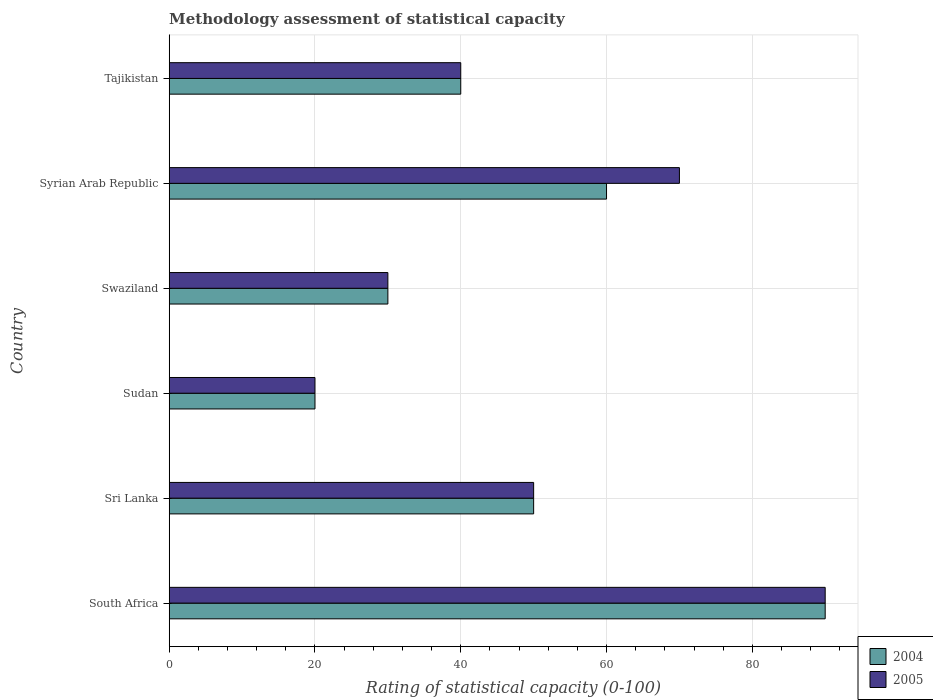How many different coloured bars are there?
Keep it short and to the point. 2. Are the number of bars on each tick of the Y-axis equal?
Your answer should be compact. Yes. How many bars are there on the 3rd tick from the top?
Your answer should be compact. 2. What is the label of the 2nd group of bars from the top?
Offer a very short reply. Syrian Arab Republic. In how many cases, is the number of bars for a given country not equal to the number of legend labels?
Offer a terse response. 0. What is the rating of statistical capacity in 2004 in Swaziland?
Your answer should be compact. 30. Across all countries, what is the minimum rating of statistical capacity in 2005?
Make the answer very short. 20. In which country was the rating of statistical capacity in 2004 maximum?
Give a very brief answer. South Africa. In which country was the rating of statistical capacity in 2005 minimum?
Give a very brief answer. Sudan. What is the total rating of statistical capacity in 2005 in the graph?
Your response must be concise. 300. What is the difference between the rating of statistical capacity in 2005 and rating of statistical capacity in 2004 in Sudan?
Keep it short and to the point. 0. Is the rating of statistical capacity in 2005 in Sri Lanka less than that in Swaziland?
Your answer should be compact. No. What is the difference between the highest and the second highest rating of statistical capacity in 2004?
Keep it short and to the point. 30. In how many countries, is the rating of statistical capacity in 2005 greater than the average rating of statistical capacity in 2005 taken over all countries?
Keep it short and to the point. 2. Is the sum of the rating of statistical capacity in 2004 in Sri Lanka and Sudan greater than the maximum rating of statistical capacity in 2005 across all countries?
Keep it short and to the point. No. Does the graph contain grids?
Give a very brief answer. Yes. How are the legend labels stacked?
Ensure brevity in your answer.  Vertical. What is the title of the graph?
Keep it short and to the point. Methodology assessment of statistical capacity. What is the label or title of the X-axis?
Offer a terse response. Rating of statistical capacity (0-100). What is the label or title of the Y-axis?
Your response must be concise. Country. What is the Rating of statistical capacity (0-100) of 2004 in Sri Lanka?
Give a very brief answer. 50. What is the Rating of statistical capacity (0-100) of 2004 in Sudan?
Your answer should be very brief. 20. What is the Rating of statistical capacity (0-100) of 2005 in Sudan?
Provide a succinct answer. 20. What is the Rating of statistical capacity (0-100) in 2004 in Swaziland?
Provide a short and direct response. 30. What is the Rating of statistical capacity (0-100) in 2005 in Swaziland?
Ensure brevity in your answer.  30. What is the Rating of statistical capacity (0-100) in 2004 in Syrian Arab Republic?
Provide a succinct answer. 60. What is the Rating of statistical capacity (0-100) in 2004 in Tajikistan?
Provide a short and direct response. 40. What is the Rating of statistical capacity (0-100) of 2005 in Tajikistan?
Your answer should be compact. 40. Across all countries, what is the maximum Rating of statistical capacity (0-100) of 2005?
Keep it short and to the point. 90. What is the total Rating of statistical capacity (0-100) of 2004 in the graph?
Give a very brief answer. 290. What is the total Rating of statistical capacity (0-100) of 2005 in the graph?
Your answer should be very brief. 300. What is the difference between the Rating of statistical capacity (0-100) of 2004 in South Africa and that in Sri Lanka?
Provide a succinct answer. 40. What is the difference between the Rating of statistical capacity (0-100) of 2004 in South Africa and that in Syrian Arab Republic?
Keep it short and to the point. 30. What is the difference between the Rating of statistical capacity (0-100) in 2004 in South Africa and that in Tajikistan?
Provide a short and direct response. 50. What is the difference between the Rating of statistical capacity (0-100) in 2005 in South Africa and that in Tajikistan?
Your answer should be compact. 50. What is the difference between the Rating of statistical capacity (0-100) of 2004 in Sri Lanka and that in Swaziland?
Keep it short and to the point. 20. What is the difference between the Rating of statistical capacity (0-100) of 2005 in Sri Lanka and that in Swaziland?
Your answer should be compact. 20. What is the difference between the Rating of statistical capacity (0-100) of 2004 in Sri Lanka and that in Syrian Arab Republic?
Your answer should be compact. -10. What is the difference between the Rating of statistical capacity (0-100) in 2005 in Sri Lanka and that in Syrian Arab Republic?
Offer a terse response. -20. What is the difference between the Rating of statistical capacity (0-100) in 2004 in Sudan and that in Swaziland?
Offer a terse response. -10. What is the difference between the Rating of statistical capacity (0-100) of 2005 in Sudan and that in Syrian Arab Republic?
Keep it short and to the point. -50. What is the difference between the Rating of statistical capacity (0-100) in 2004 in Sudan and that in Tajikistan?
Keep it short and to the point. -20. What is the difference between the Rating of statistical capacity (0-100) in 2005 in Swaziland and that in Syrian Arab Republic?
Provide a succinct answer. -40. What is the difference between the Rating of statistical capacity (0-100) of 2004 in Swaziland and that in Tajikistan?
Keep it short and to the point. -10. What is the difference between the Rating of statistical capacity (0-100) of 2004 in South Africa and the Rating of statistical capacity (0-100) of 2005 in Sri Lanka?
Offer a very short reply. 40. What is the difference between the Rating of statistical capacity (0-100) of 2004 in South Africa and the Rating of statistical capacity (0-100) of 2005 in Sudan?
Provide a succinct answer. 70. What is the difference between the Rating of statistical capacity (0-100) of 2004 in South Africa and the Rating of statistical capacity (0-100) of 2005 in Swaziland?
Keep it short and to the point. 60. What is the difference between the Rating of statistical capacity (0-100) in 2004 in South Africa and the Rating of statistical capacity (0-100) in 2005 in Syrian Arab Republic?
Provide a succinct answer. 20. What is the difference between the Rating of statistical capacity (0-100) of 2004 in South Africa and the Rating of statistical capacity (0-100) of 2005 in Tajikistan?
Ensure brevity in your answer.  50. What is the difference between the Rating of statistical capacity (0-100) of 2004 in Sri Lanka and the Rating of statistical capacity (0-100) of 2005 in Syrian Arab Republic?
Provide a succinct answer. -20. What is the difference between the Rating of statistical capacity (0-100) in 2004 in Sudan and the Rating of statistical capacity (0-100) in 2005 in Swaziland?
Your answer should be compact. -10. What is the difference between the Rating of statistical capacity (0-100) of 2004 in Sudan and the Rating of statistical capacity (0-100) of 2005 in Syrian Arab Republic?
Provide a succinct answer. -50. What is the difference between the Rating of statistical capacity (0-100) of 2004 in Swaziland and the Rating of statistical capacity (0-100) of 2005 in Tajikistan?
Ensure brevity in your answer.  -10. What is the difference between the Rating of statistical capacity (0-100) in 2004 in Syrian Arab Republic and the Rating of statistical capacity (0-100) in 2005 in Tajikistan?
Make the answer very short. 20. What is the average Rating of statistical capacity (0-100) of 2004 per country?
Ensure brevity in your answer.  48.33. What is the average Rating of statistical capacity (0-100) in 2005 per country?
Your response must be concise. 50. What is the difference between the Rating of statistical capacity (0-100) in 2004 and Rating of statistical capacity (0-100) in 2005 in South Africa?
Your answer should be very brief. 0. What is the difference between the Rating of statistical capacity (0-100) in 2004 and Rating of statistical capacity (0-100) in 2005 in Sri Lanka?
Provide a succinct answer. 0. What is the difference between the Rating of statistical capacity (0-100) of 2004 and Rating of statistical capacity (0-100) of 2005 in Sudan?
Offer a very short reply. 0. What is the difference between the Rating of statistical capacity (0-100) of 2004 and Rating of statistical capacity (0-100) of 2005 in Swaziland?
Keep it short and to the point. 0. What is the difference between the Rating of statistical capacity (0-100) in 2004 and Rating of statistical capacity (0-100) in 2005 in Syrian Arab Republic?
Make the answer very short. -10. What is the difference between the Rating of statistical capacity (0-100) in 2004 and Rating of statistical capacity (0-100) in 2005 in Tajikistan?
Offer a very short reply. 0. What is the ratio of the Rating of statistical capacity (0-100) of 2004 in South Africa to that in Sri Lanka?
Ensure brevity in your answer.  1.8. What is the ratio of the Rating of statistical capacity (0-100) in 2005 in South Africa to that in Sri Lanka?
Ensure brevity in your answer.  1.8. What is the ratio of the Rating of statistical capacity (0-100) in 2005 in South Africa to that in Sudan?
Offer a terse response. 4.5. What is the ratio of the Rating of statistical capacity (0-100) in 2005 in South Africa to that in Swaziland?
Provide a short and direct response. 3. What is the ratio of the Rating of statistical capacity (0-100) in 2005 in South Africa to that in Syrian Arab Republic?
Your response must be concise. 1.29. What is the ratio of the Rating of statistical capacity (0-100) of 2004 in South Africa to that in Tajikistan?
Your answer should be very brief. 2.25. What is the ratio of the Rating of statistical capacity (0-100) in 2005 in South Africa to that in Tajikistan?
Keep it short and to the point. 2.25. What is the ratio of the Rating of statistical capacity (0-100) of 2004 in Sri Lanka to that in Sudan?
Offer a terse response. 2.5. What is the ratio of the Rating of statistical capacity (0-100) of 2005 in Sri Lanka to that in Sudan?
Offer a very short reply. 2.5. What is the ratio of the Rating of statistical capacity (0-100) of 2005 in Sri Lanka to that in Swaziland?
Provide a succinct answer. 1.67. What is the ratio of the Rating of statistical capacity (0-100) of 2005 in Sri Lanka to that in Syrian Arab Republic?
Make the answer very short. 0.71. What is the ratio of the Rating of statistical capacity (0-100) in 2005 in Sri Lanka to that in Tajikistan?
Your answer should be very brief. 1.25. What is the ratio of the Rating of statistical capacity (0-100) of 2004 in Sudan to that in Swaziland?
Offer a terse response. 0.67. What is the ratio of the Rating of statistical capacity (0-100) in 2004 in Sudan to that in Syrian Arab Republic?
Offer a very short reply. 0.33. What is the ratio of the Rating of statistical capacity (0-100) in 2005 in Sudan to that in Syrian Arab Republic?
Your answer should be compact. 0.29. What is the ratio of the Rating of statistical capacity (0-100) in 2004 in Swaziland to that in Syrian Arab Republic?
Offer a terse response. 0.5. What is the ratio of the Rating of statistical capacity (0-100) of 2005 in Swaziland to that in Syrian Arab Republic?
Provide a short and direct response. 0.43. What is the ratio of the Rating of statistical capacity (0-100) in 2004 in Swaziland to that in Tajikistan?
Give a very brief answer. 0.75. What is the ratio of the Rating of statistical capacity (0-100) of 2005 in Syrian Arab Republic to that in Tajikistan?
Ensure brevity in your answer.  1.75. What is the difference between the highest and the second highest Rating of statistical capacity (0-100) of 2004?
Provide a short and direct response. 30. What is the difference between the highest and the second highest Rating of statistical capacity (0-100) of 2005?
Make the answer very short. 20. What is the difference between the highest and the lowest Rating of statistical capacity (0-100) of 2004?
Offer a very short reply. 70. What is the difference between the highest and the lowest Rating of statistical capacity (0-100) of 2005?
Provide a short and direct response. 70. 